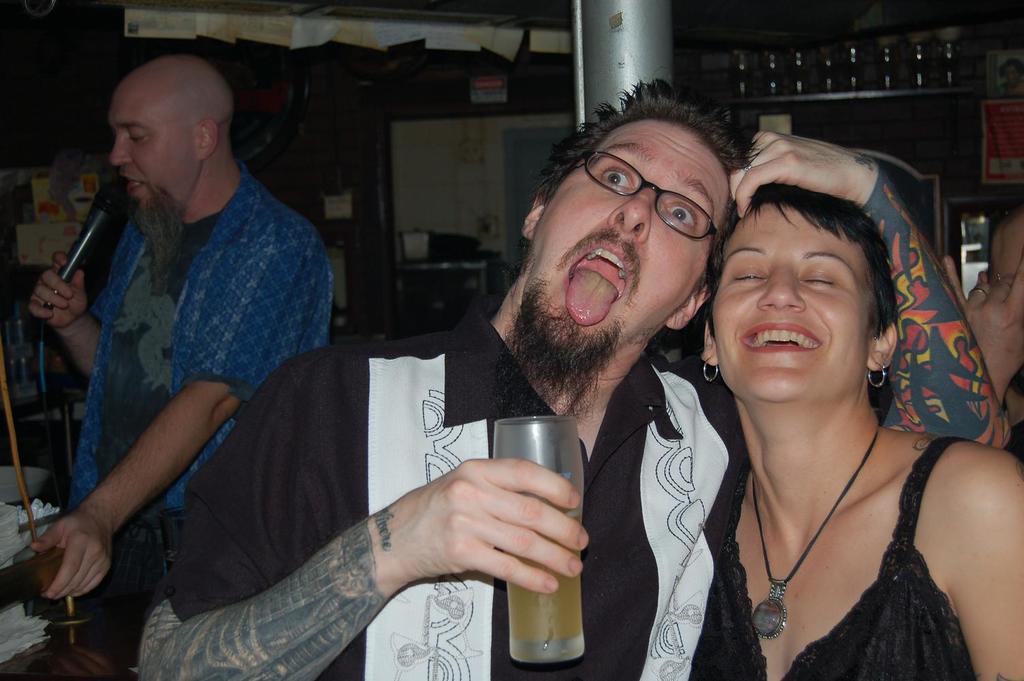Can you describe this image briefly? in this image there is a person with black shirt and tattoo on his right hand and he is holding the glass. There is a woman with black dress standing and laughing. At the back there is a man with blue shirt, he is holding a microphone. At the back there is a door. At the top there are papers. 